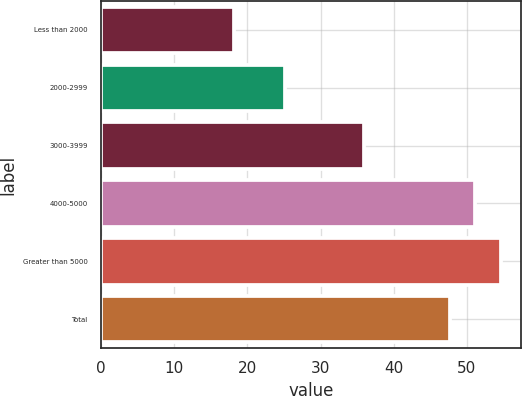Convert chart. <chart><loc_0><loc_0><loc_500><loc_500><bar_chart><fcel>Less than 2000<fcel>2000-2999<fcel>3000-3999<fcel>4000-5000<fcel>Greater than 5000<fcel>Total<nl><fcel>18.17<fcel>25.12<fcel>35.98<fcel>51.16<fcel>54.67<fcel>47.64<nl></chart> 